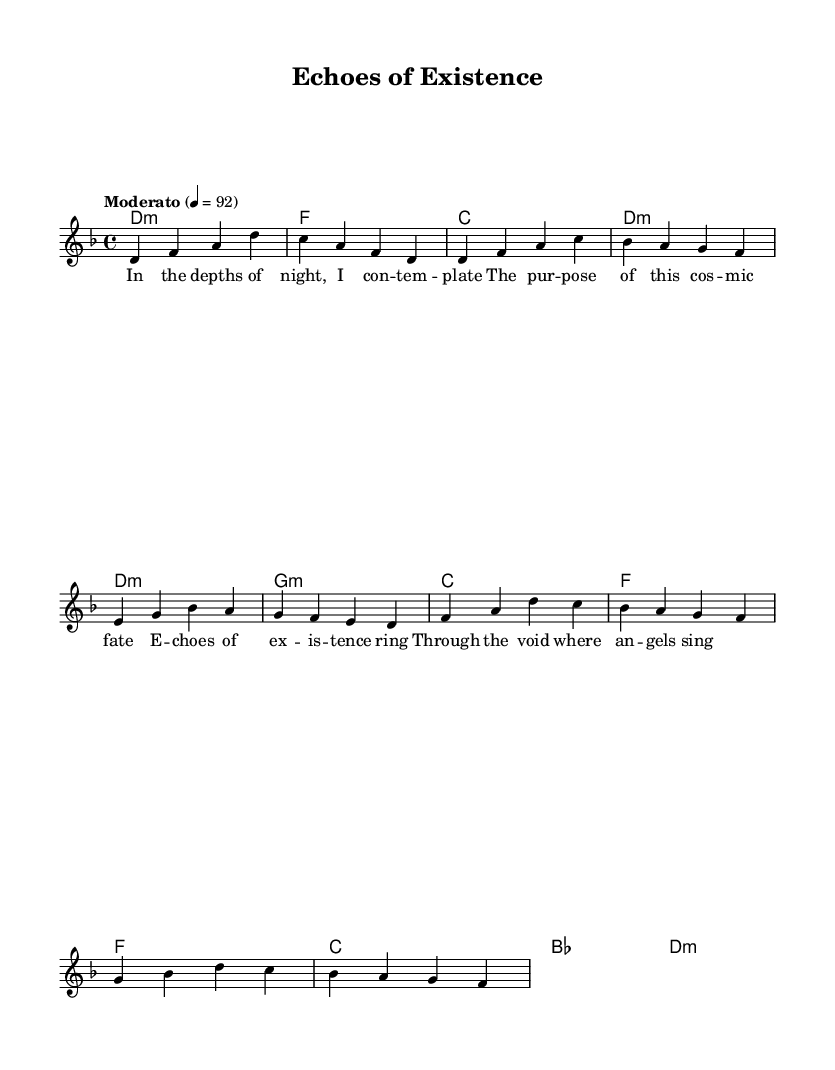What is the key signature of this music? The key signature is identified by looking at the initial markings in the global section, which indicates D minor has one flat (B flat).
Answer: D minor What is the time signature of this piece? The time signature is located in the global section, where it shows 4/4, meaning there are four beats in a measure.
Answer: 4/4 What is the tempo marking for this composition? The tempo is indicated in the global section with the term "Moderato" and a metronome marking of 92 beats per minute.
Answer: Moderato 4 = 92 How many measures are there in the chorus? By counting the measures in the chorus section of the sheet music, we see there are four measures denoted by the sets of notes.
Answer: 4 What is the first line of the verse lyrics? The first line can be extracted from the lyric mode section labeled under the verse, which reads "In the depths of night, I con -- tem -- plate."
Answer: In the depths of night, I con -- tem -- plate Which chords are used in the chorus? The chords are specified in the harmonies section; for the chorus, they are F, C, B flat, and D minor.
Answer: F, C, B flat, D minor How does the melody of the verse begin? The melody is shown in the relative section and begins with the note D in the first measure, leading the melodic line.
Answer: D 